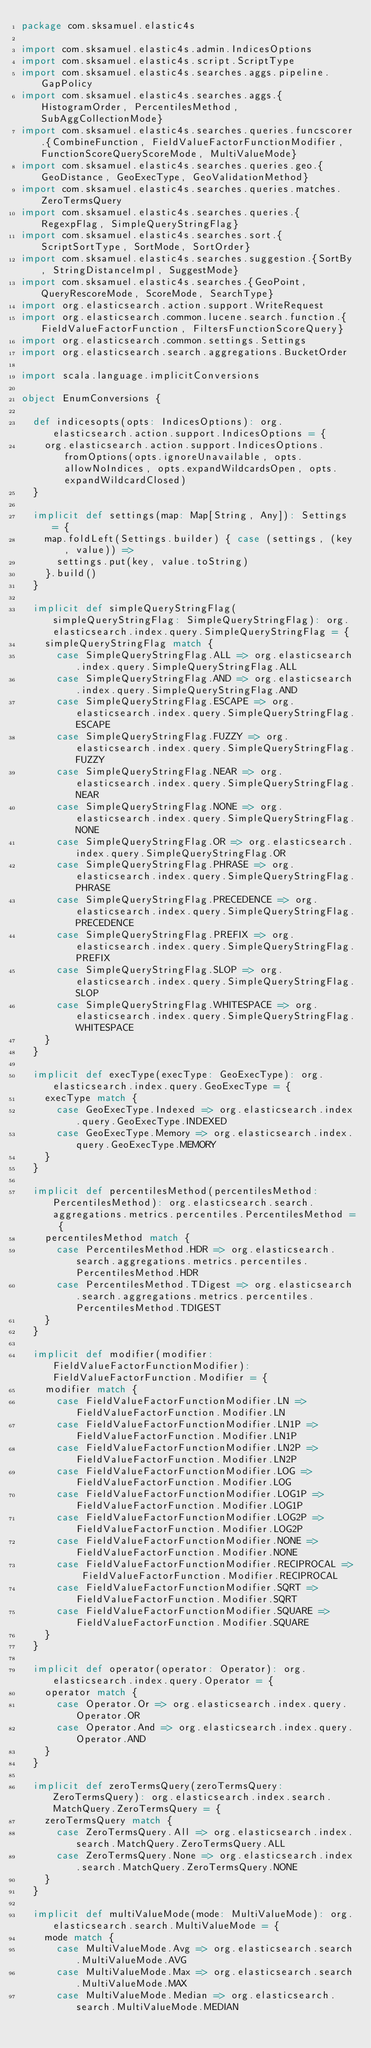Convert code to text. <code><loc_0><loc_0><loc_500><loc_500><_Scala_>package com.sksamuel.elastic4s

import com.sksamuel.elastic4s.admin.IndicesOptions
import com.sksamuel.elastic4s.script.ScriptType
import com.sksamuel.elastic4s.searches.aggs.pipeline.GapPolicy
import com.sksamuel.elastic4s.searches.aggs.{HistogramOrder, PercentilesMethod, SubAggCollectionMode}
import com.sksamuel.elastic4s.searches.queries.funcscorer.{CombineFunction, FieldValueFactorFunctionModifier, FunctionScoreQueryScoreMode, MultiValueMode}
import com.sksamuel.elastic4s.searches.queries.geo.{GeoDistance, GeoExecType, GeoValidationMethod}
import com.sksamuel.elastic4s.searches.queries.matches.ZeroTermsQuery
import com.sksamuel.elastic4s.searches.queries.{RegexpFlag, SimpleQueryStringFlag}
import com.sksamuel.elastic4s.searches.sort.{ScriptSortType, SortMode, SortOrder}
import com.sksamuel.elastic4s.searches.suggestion.{SortBy, StringDistanceImpl, SuggestMode}
import com.sksamuel.elastic4s.searches.{GeoPoint, QueryRescoreMode, ScoreMode, SearchType}
import org.elasticsearch.action.support.WriteRequest
import org.elasticsearch.common.lucene.search.function.{FieldValueFactorFunction, FiltersFunctionScoreQuery}
import org.elasticsearch.common.settings.Settings
import org.elasticsearch.search.aggregations.BucketOrder

import scala.language.implicitConversions

object EnumConversions {

  def indicesopts(opts: IndicesOptions): org.elasticsearch.action.support.IndicesOptions = {
    org.elasticsearch.action.support.IndicesOptions.fromOptions(opts.ignoreUnavailable, opts.allowNoIndices, opts.expandWildcardsOpen, opts.expandWildcardClosed)
  }

  implicit def settings(map: Map[String, Any]): Settings = {
    map.foldLeft(Settings.builder) { case (settings, (key, value)) =>
      settings.put(key, value.toString)
    }.build()
  }

  implicit def simpleQueryStringFlag(simpleQueryStringFlag: SimpleQueryStringFlag): org.elasticsearch.index.query.SimpleQueryStringFlag = {
    simpleQueryStringFlag match {
      case SimpleQueryStringFlag.ALL => org.elasticsearch.index.query.SimpleQueryStringFlag.ALL
      case SimpleQueryStringFlag.AND => org.elasticsearch.index.query.SimpleQueryStringFlag.AND
      case SimpleQueryStringFlag.ESCAPE => org.elasticsearch.index.query.SimpleQueryStringFlag.ESCAPE
      case SimpleQueryStringFlag.FUZZY => org.elasticsearch.index.query.SimpleQueryStringFlag.FUZZY
      case SimpleQueryStringFlag.NEAR => org.elasticsearch.index.query.SimpleQueryStringFlag.NEAR
      case SimpleQueryStringFlag.NONE => org.elasticsearch.index.query.SimpleQueryStringFlag.NONE
      case SimpleQueryStringFlag.OR => org.elasticsearch.index.query.SimpleQueryStringFlag.OR
      case SimpleQueryStringFlag.PHRASE => org.elasticsearch.index.query.SimpleQueryStringFlag.PHRASE
      case SimpleQueryStringFlag.PRECEDENCE => org.elasticsearch.index.query.SimpleQueryStringFlag.PRECEDENCE
      case SimpleQueryStringFlag.PREFIX => org.elasticsearch.index.query.SimpleQueryStringFlag.PREFIX
      case SimpleQueryStringFlag.SLOP => org.elasticsearch.index.query.SimpleQueryStringFlag.SLOP
      case SimpleQueryStringFlag.WHITESPACE => org.elasticsearch.index.query.SimpleQueryStringFlag.WHITESPACE
    }
  }

  implicit def execType(execType: GeoExecType): org.elasticsearch.index.query.GeoExecType = {
    execType match {
      case GeoExecType.Indexed => org.elasticsearch.index.query.GeoExecType.INDEXED
      case GeoExecType.Memory => org.elasticsearch.index.query.GeoExecType.MEMORY
    }
  }

  implicit def percentilesMethod(percentilesMethod: PercentilesMethod): org.elasticsearch.search.aggregations.metrics.percentiles.PercentilesMethod = {
    percentilesMethod match {
      case PercentilesMethod.HDR => org.elasticsearch.search.aggregations.metrics.percentiles.PercentilesMethod.HDR
      case PercentilesMethod.TDigest => org.elasticsearch.search.aggregations.metrics.percentiles.PercentilesMethod.TDIGEST
    }
  }

  implicit def modifier(modifier: FieldValueFactorFunctionModifier): FieldValueFactorFunction.Modifier = {
    modifier match {
      case FieldValueFactorFunctionModifier.LN => FieldValueFactorFunction.Modifier.LN
      case FieldValueFactorFunctionModifier.LN1P => FieldValueFactorFunction.Modifier.LN1P
      case FieldValueFactorFunctionModifier.LN2P => FieldValueFactorFunction.Modifier.LN2P
      case FieldValueFactorFunctionModifier.LOG => FieldValueFactorFunction.Modifier.LOG
      case FieldValueFactorFunctionModifier.LOG1P => FieldValueFactorFunction.Modifier.LOG1P
      case FieldValueFactorFunctionModifier.LOG2P => FieldValueFactorFunction.Modifier.LOG2P
      case FieldValueFactorFunctionModifier.NONE => FieldValueFactorFunction.Modifier.NONE
      case FieldValueFactorFunctionModifier.RECIPROCAL => FieldValueFactorFunction.Modifier.RECIPROCAL
      case FieldValueFactorFunctionModifier.SQRT => FieldValueFactorFunction.Modifier.SQRT
      case FieldValueFactorFunctionModifier.SQUARE => FieldValueFactorFunction.Modifier.SQUARE
    }
  }

  implicit def operator(operator: Operator): org.elasticsearch.index.query.Operator = {
    operator match {
      case Operator.Or => org.elasticsearch.index.query.Operator.OR
      case Operator.And => org.elasticsearch.index.query.Operator.AND
    }
  }

  implicit def zeroTermsQuery(zeroTermsQuery: ZeroTermsQuery): org.elasticsearch.index.search.MatchQuery.ZeroTermsQuery = {
    zeroTermsQuery match {
      case ZeroTermsQuery.All => org.elasticsearch.index.search.MatchQuery.ZeroTermsQuery.ALL
      case ZeroTermsQuery.None => org.elasticsearch.index.search.MatchQuery.ZeroTermsQuery.NONE
    }
  }

  implicit def multiValueMode(mode: MultiValueMode): org.elasticsearch.search.MultiValueMode = {
    mode match {
      case MultiValueMode.Avg => org.elasticsearch.search.MultiValueMode.AVG
      case MultiValueMode.Max => org.elasticsearch.search.MultiValueMode.MAX
      case MultiValueMode.Median => org.elasticsearch.search.MultiValueMode.MEDIAN</code> 